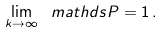Convert formula to latex. <formula><loc_0><loc_0><loc_500><loc_500>\lim _ { k \to \infty } \ m a t h d s { P } = 1 \, .</formula> 